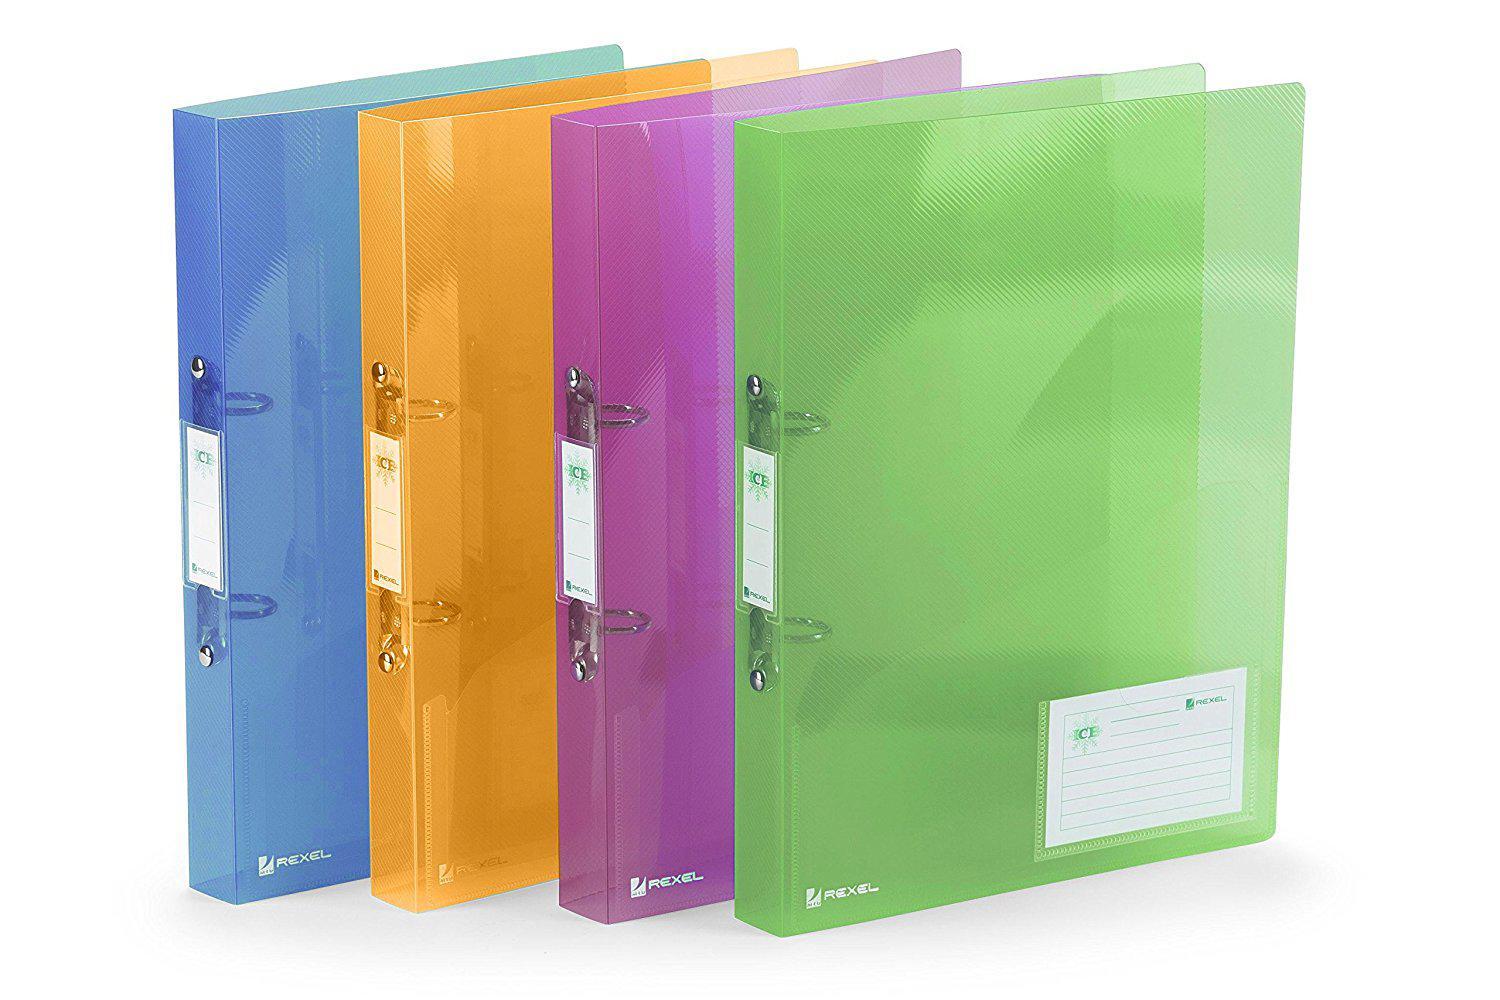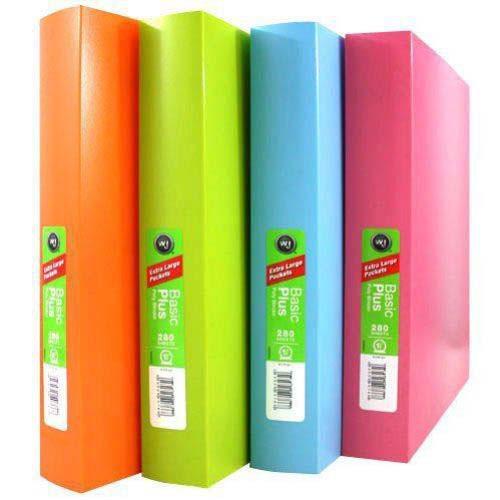The first image is the image on the left, the second image is the image on the right. Given the left and right images, does the statement "There are nine binders, all appearing to be different colors." hold true? Answer yes or no. No. The first image is the image on the left, the second image is the image on the right. Assess this claim about the two images: "There is one clear folder present.". Correct or not? Answer yes or no. No. 